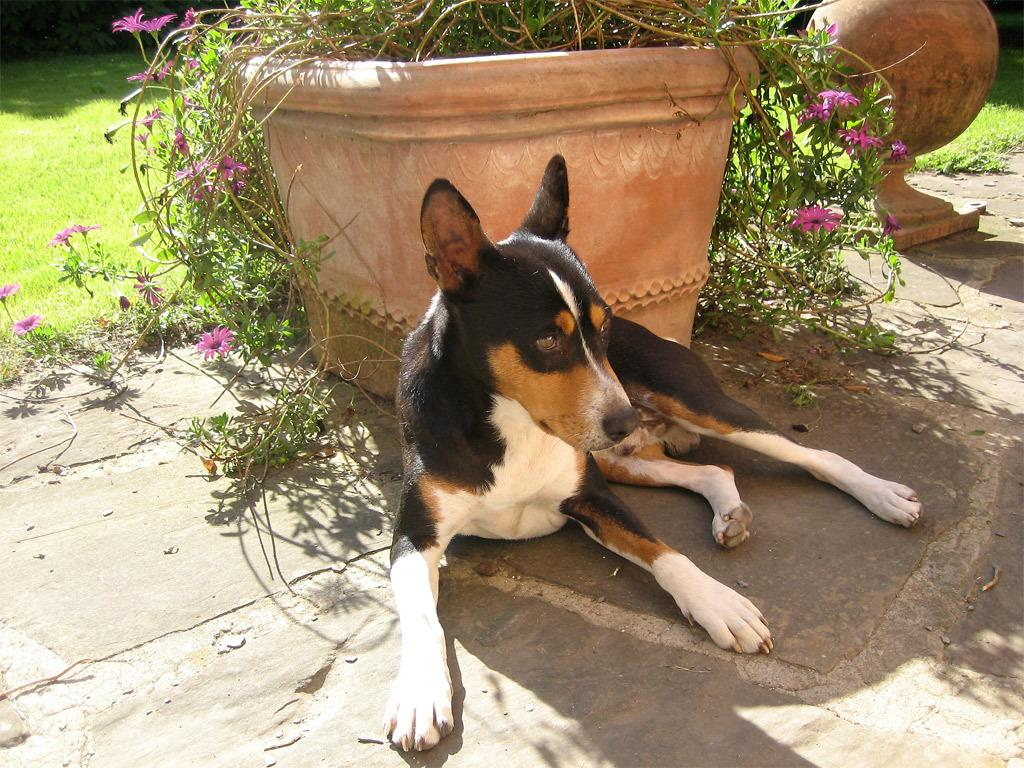What animal can be seen in the image? There is a dog in the image. Where is the dog positioned in relation to the flower pot? The dog is sitting in front of a flower pot. What type of vegetation is visible in the image? There is grass visible in the image. What can be seen in the top right corner of the image? There is a sculpture in the top right corner of the image. What country is the expert from, who is standing next to the dog in the image? There is no expert present in the image, nor is there any indication of a country. 